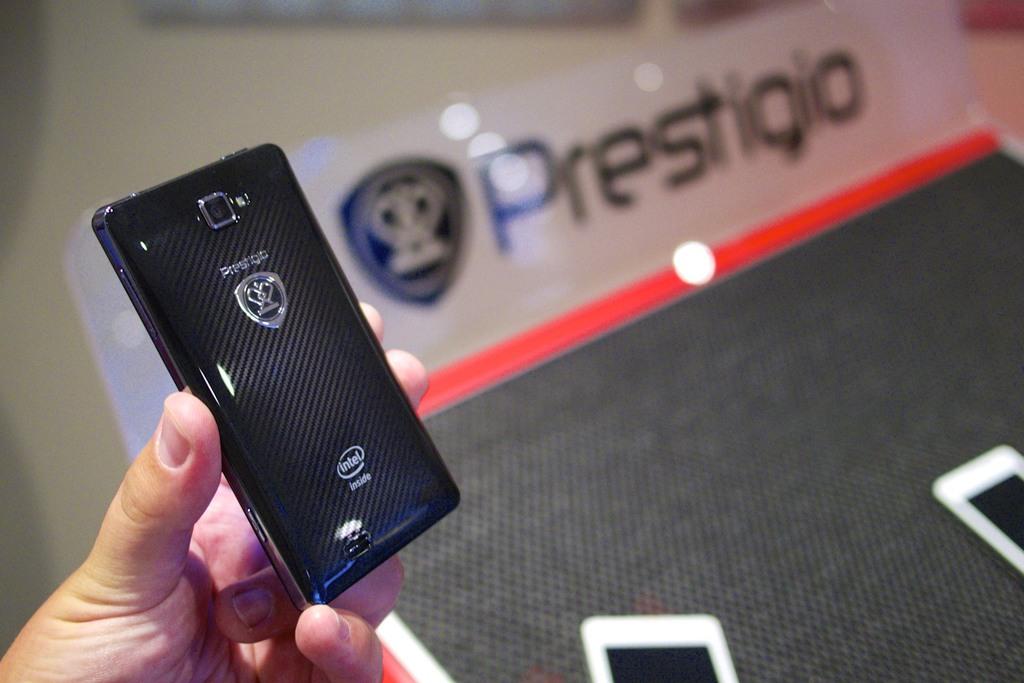Who makes this?
Ensure brevity in your answer.  Prestigio. What is the name in the logo on the bottom of the phone?
Ensure brevity in your answer.  Intel. 